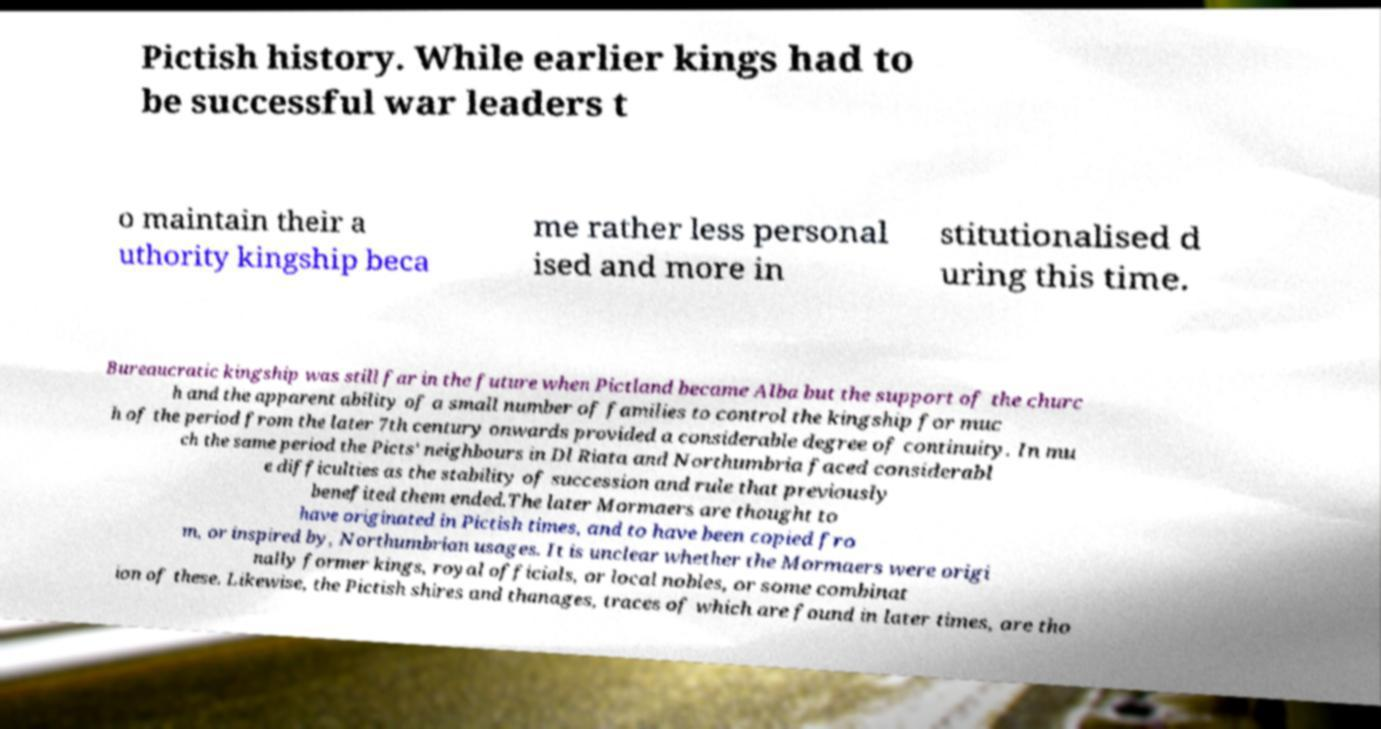What messages or text are displayed in this image? I need them in a readable, typed format. Pictish history. While earlier kings had to be successful war leaders t o maintain their a uthority kingship beca me rather less personal ised and more in stitutionalised d uring this time. Bureaucratic kingship was still far in the future when Pictland became Alba but the support of the churc h and the apparent ability of a small number of families to control the kingship for muc h of the period from the later 7th century onwards provided a considerable degree of continuity. In mu ch the same period the Picts' neighbours in Dl Riata and Northumbria faced considerabl e difficulties as the stability of succession and rule that previously benefited them ended.The later Mormaers are thought to have originated in Pictish times, and to have been copied fro m, or inspired by, Northumbrian usages. It is unclear whether the Mormaers were origi nally former kings, royal officials, or local nobles, or some combinat ion of these. Likewise, the Pictish shires and thanages, traces of which are found in later times, are tho 